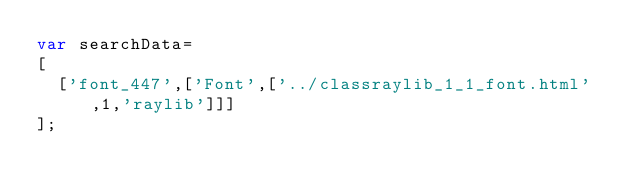<code> <loc_0><loc_0><loc_500><loc_500><_JavaScript_>var searchData=
[
  ['font_447',['Font',['../classraylib_1_1_font.html',1,'raylib']]]
];
</code> 